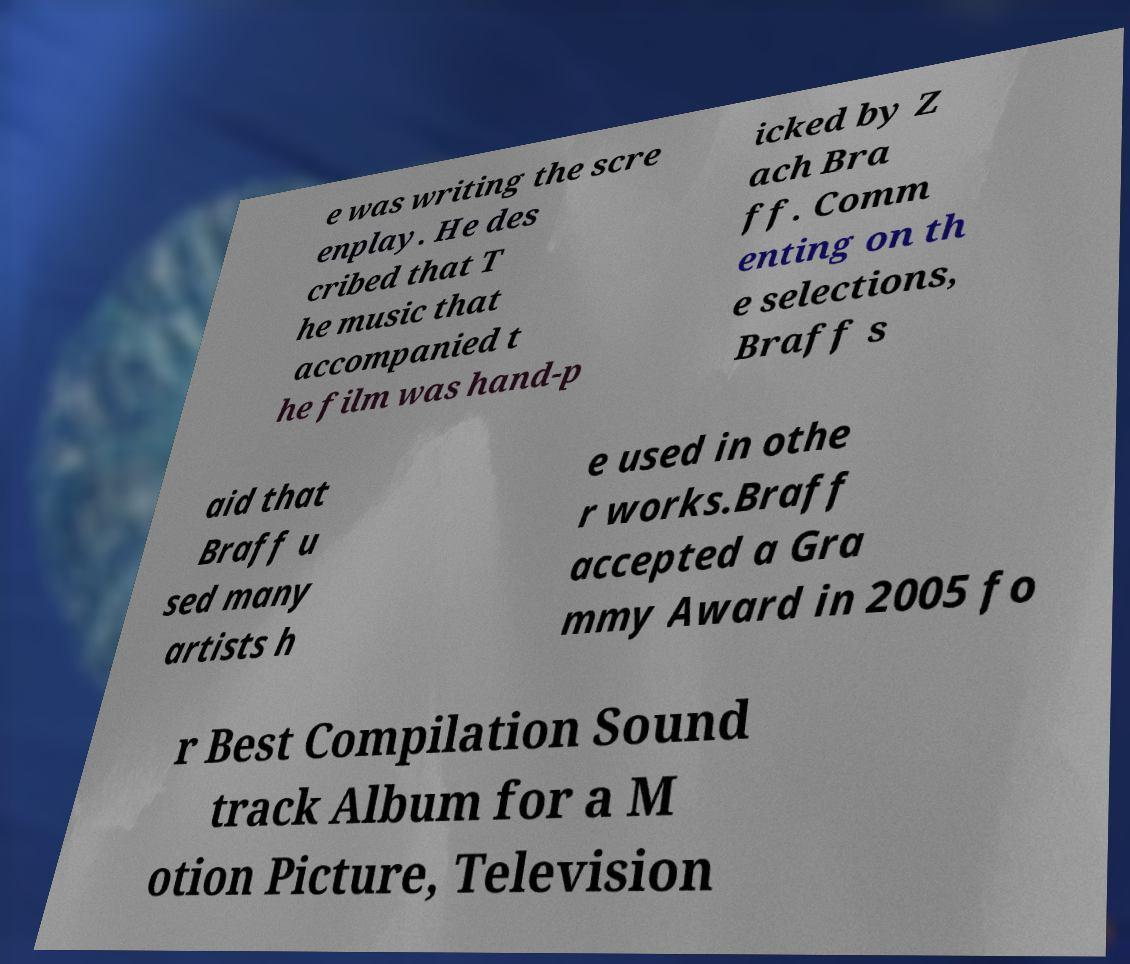There's text embedded in this image that I need extracted. Can you transcribe it verbatim? e was writing the scre enplay. He des cribed that T he music that accompanied t he film was hand-p icked by Z ach Bra ff. Comm enting on th e selections, Braff s aid that Braff u sed many artists h e used in othe r works.Braff accepted a Gra mmy Award in 2005 fo r Best Compilation Sound track Album for a M otion Picture, Television 